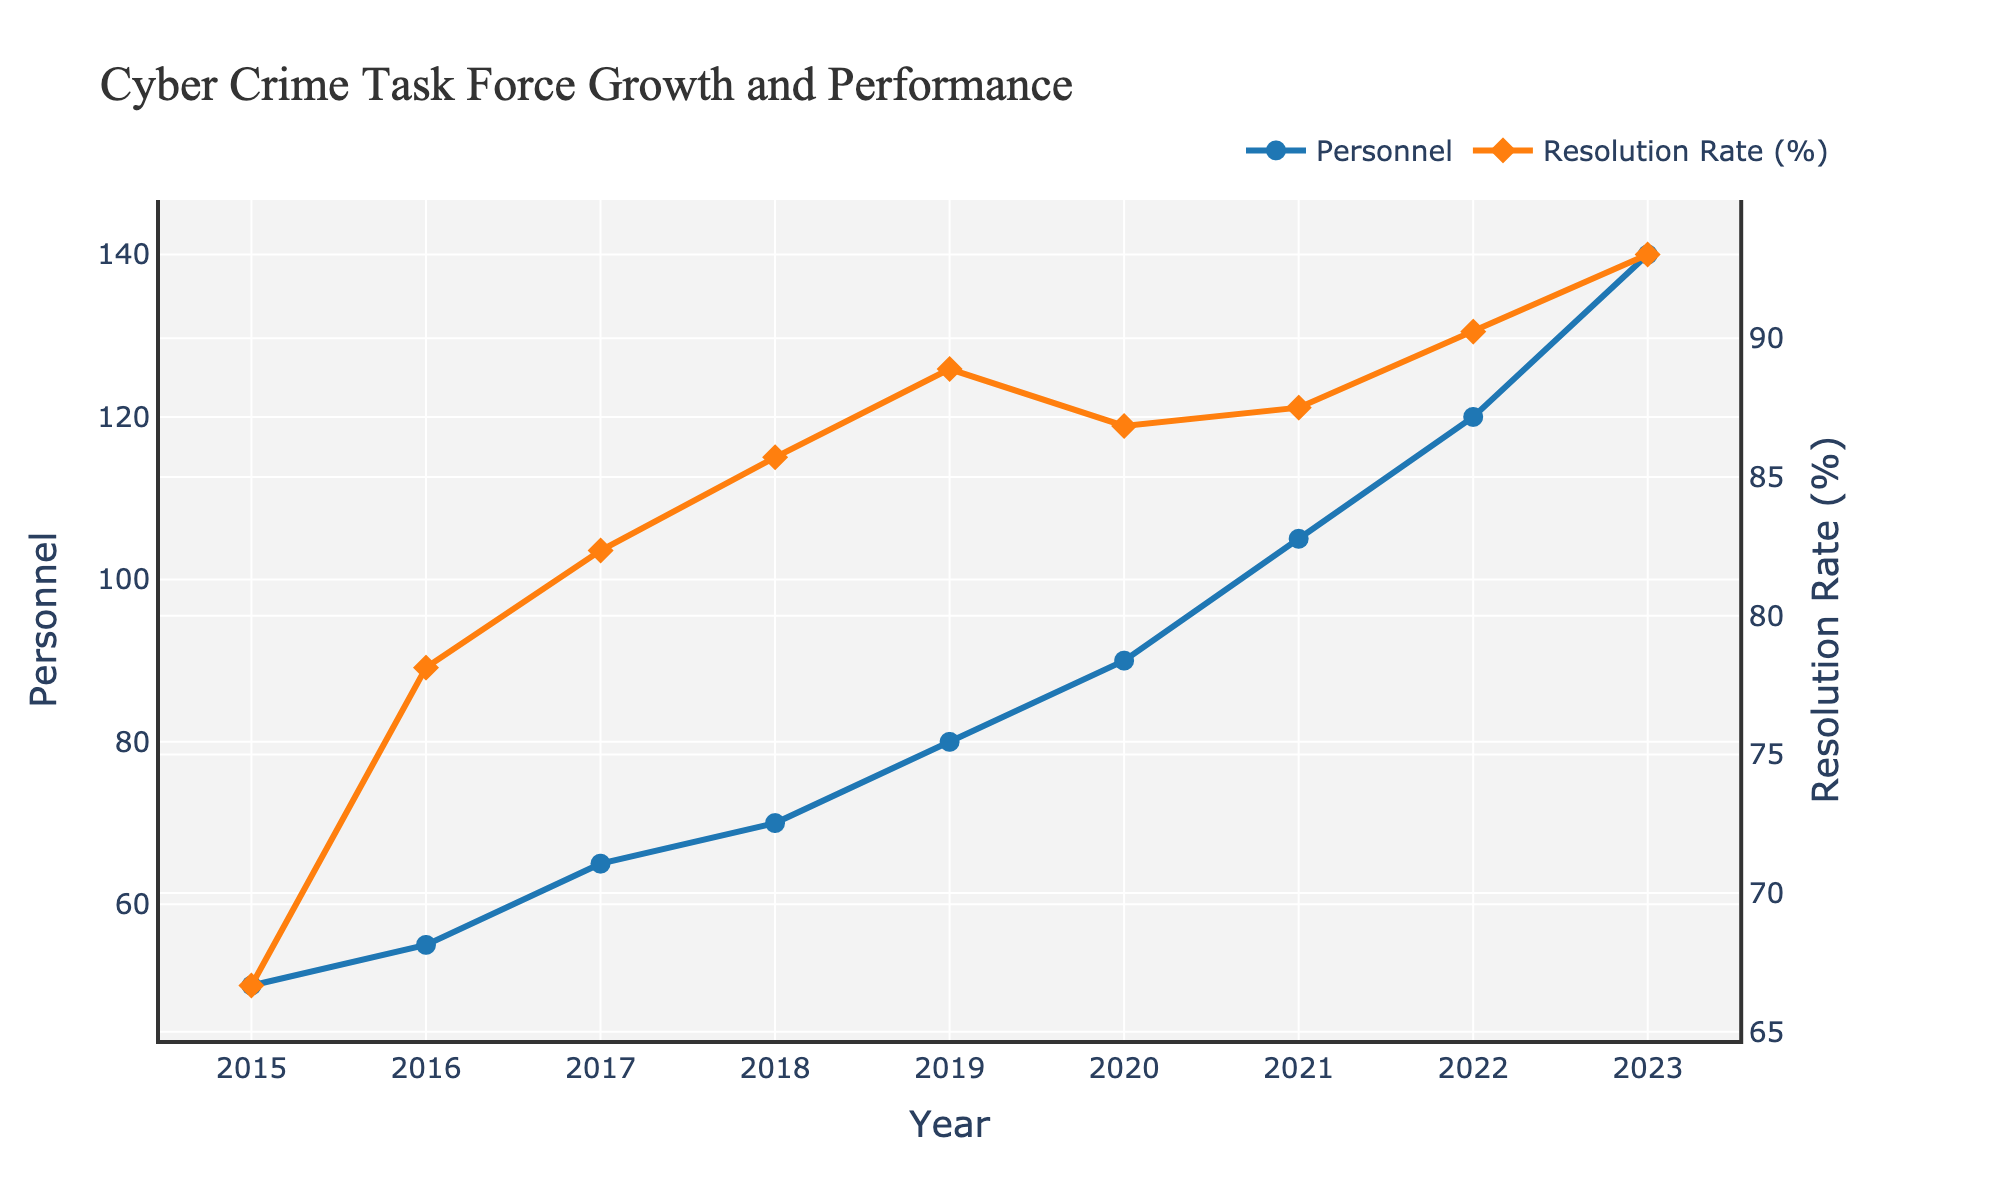What is the title of the plot? The title of the plot is located at the top center of the figure, and it provides a concise description of the content.
Answer: Cyber Crime Task Force Growth and Performance How many personnel were part of the task force in 2015? Locate the "Personnel" line (blue circles) on the graph and check the value for the year 2015 on the x-axis.
Answer: 50 How did the Resolution Rate (in %) change from 2017 to 2018? Find the "Resolution Rate" line (orange diamonds) on the graph. Identify the points for 2017 and 2018 and compare their y-values.
Answer: Increased by 3.36% In which year did the task force see the highest growth rate in personnel? Identify the year with the steepest slope (largest vertical change) in the "Personnel" line between consecutive years and confirm by the data points.
Answer: 2017 What is the relationship between the number of personnel and the Case Resolution Rate over time? Observe the trends of both lines (Personnel and Resolution Rate). Notice that as the number of personnel increases, the Resolution Rate also rises.
Answer: Both increase Which year had the highest Resolution Rate? Refer to the "Resolution Rate" line and identify the highest point along the y-axis. Note the corresponding year on the x-axis.
Answer: 2023 Between which years did the number of personnel increase by the same absolute amount? Check the increments in the "Personnel" line between different consecutive years, and find overlapping increments. E.g., 2016-2017 and 2022-2023 both show an increase of 15 personnel.
Answer: Between 2016-2017, 2021-2022, and 2022-2023 By how much did the Resolution Rate change from 2020 to 2021? Refer to the "Resolution Rate" line and compare the y-values for the years 2020 and 2021. Compute their difference.
Answer: Increased by 0.66% What was the total number of cases in 2019? This information needs to be answered concerning the total cases on the y-axis. The provided plot only contains certain variables, so it should directly refer to the given data.
Answer: 360 (based on provided data) For which year was the increase in case resolutions the highest? Identify the year-to-year difference in case resolutions by checking the steepest increase in the "Resolution Rate" line or referring to the given data.
Answer: 2016 (50 increase) 